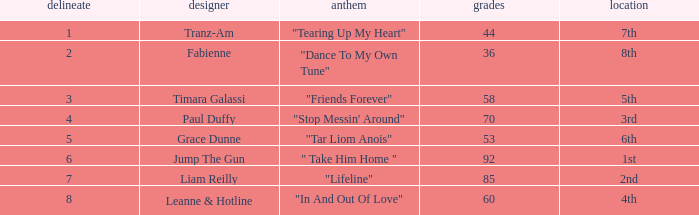What's the song of artist liam reilly? "Lifeline". 